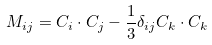<formula> <loc_0><loc_0><loc_500><loc_500>M _ { i j } = C _ { i } \cdot C _ { j } - \frac { 1 } { 3 } \delta _ { i j } C _ { k } \cdot C _ { k }</formula> 